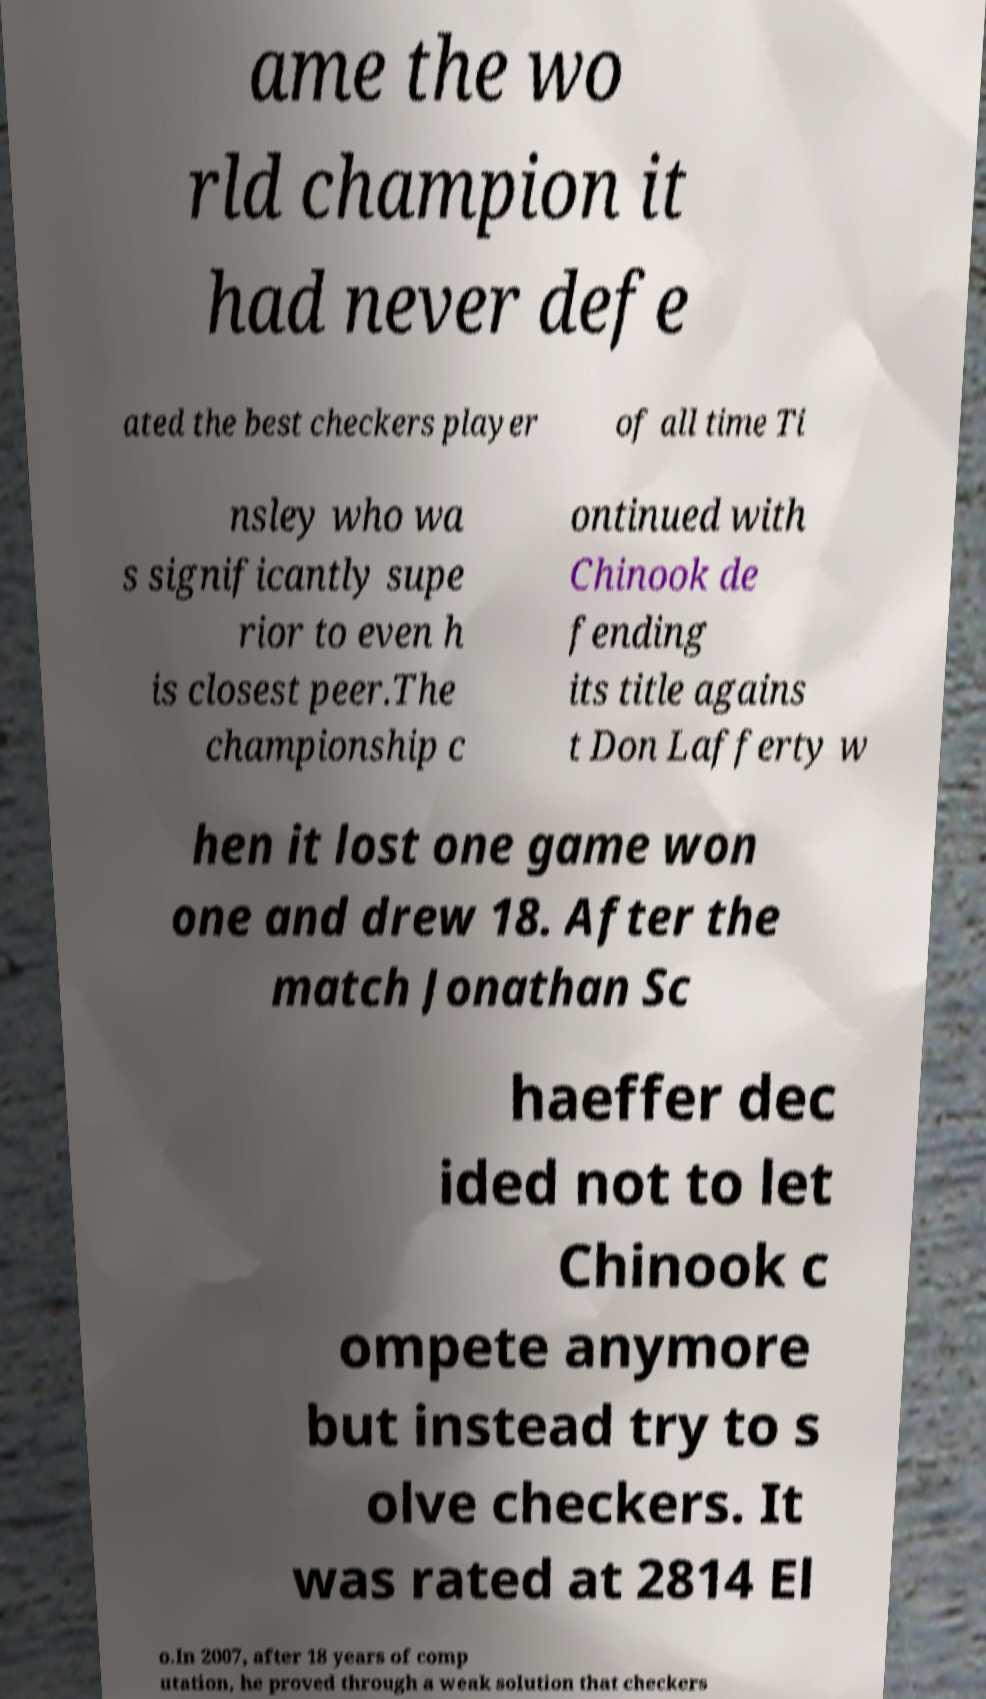Please identify and transcribe the text found in this image. ame the wo rld champion it had never defe ated the best checkers player of all time Ti nsley who wa s significantly supe rior to even h is closest peer.The championship c ontinued with Chinook de fending its title agains t Don Lafferty w hen it lost one game won one and drew 18. After the match Jonathan Sc haeffer dec ided not to let Chinook c ompete anymore but instead try to s olve checkers. It was rated at 2814 El o.In 2007, after 18 years of comp utation, he proved through a weak solution that checkers 